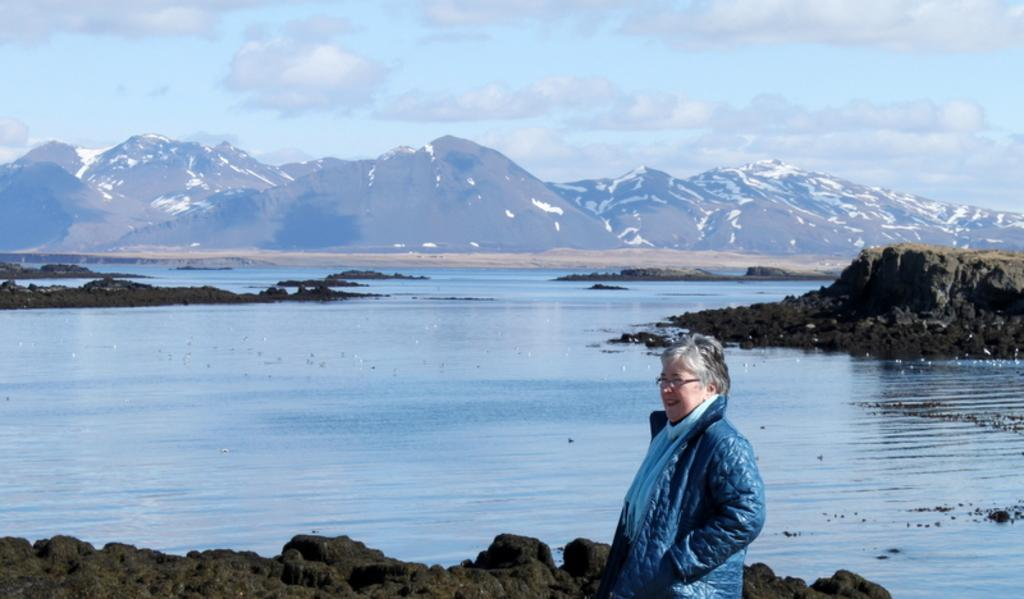Who is present in the image? There is a woman in the image. What is the woman doing in the image? The woman is standing. What is the woman wearing in the image? The woman is wearing a jacket and spectacles. What can be seen in the background of the image? There are mountains, water, and the sky visible in the background of the image. What type of jar is the woman holding in the image? There is no jar present in the image; the woman is not holding anything. What book is the woman reading in the image? There is no book or reading activity depicted in the image. 